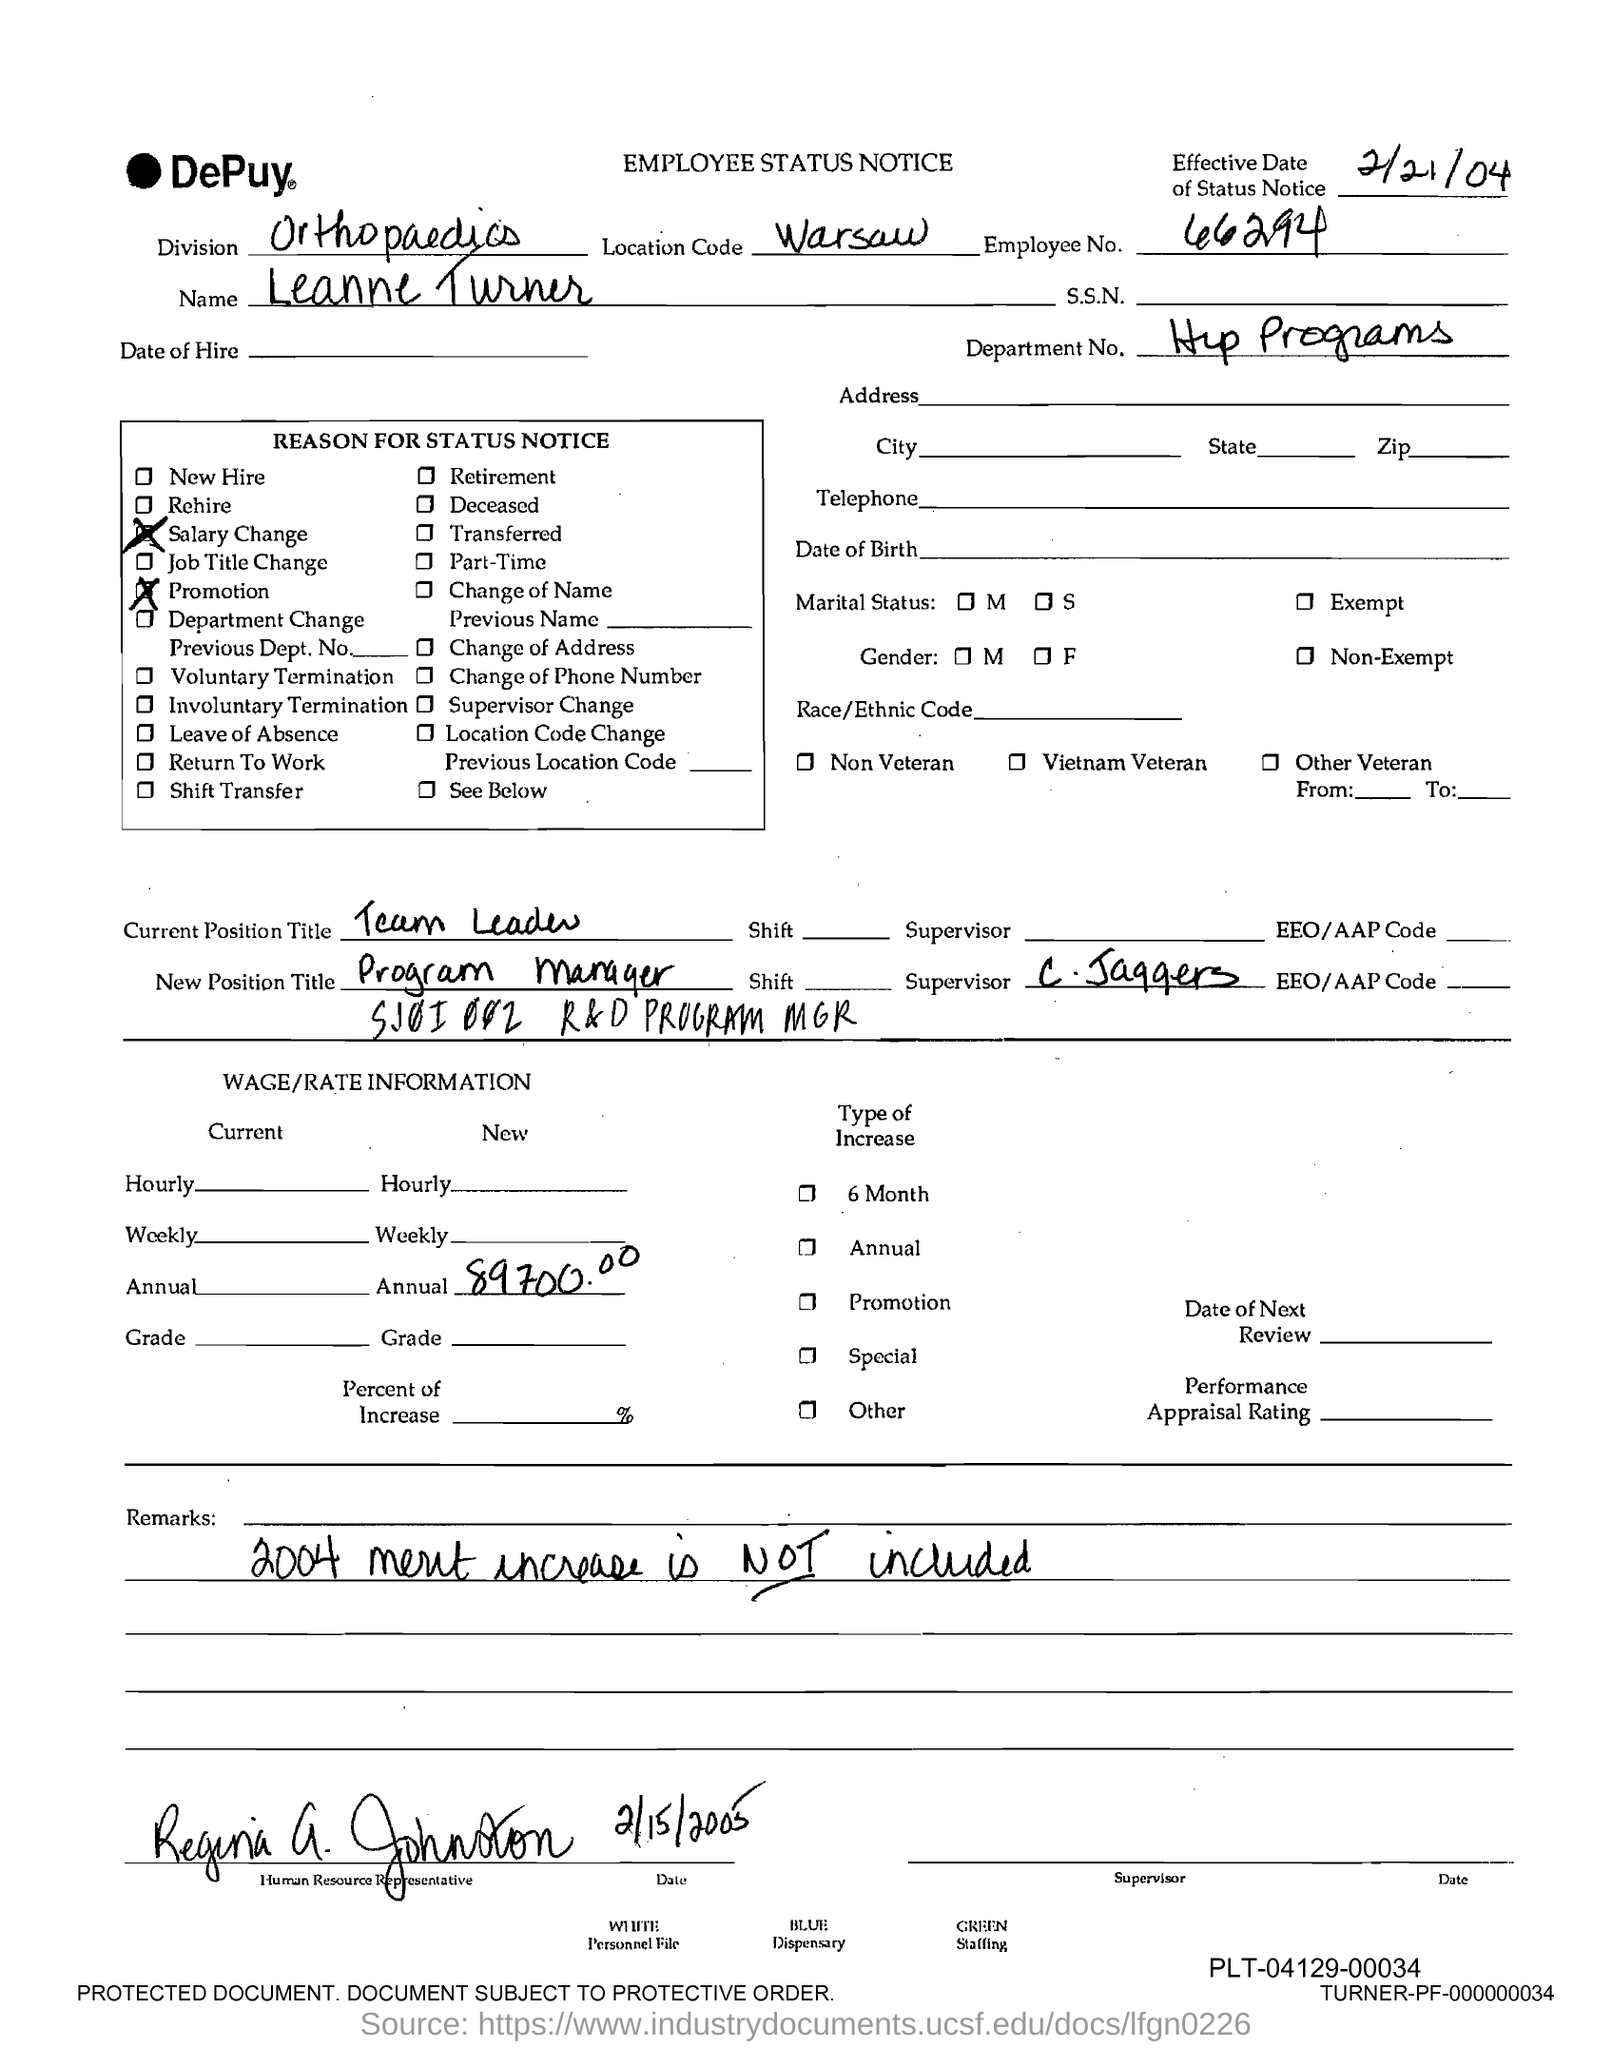What is the Employee No.?
Ensure brevity in your answer.  66294. What is the name of the Employee?
Provide a short and direct response. Leanne Turner. What is the Department No.?
Provide a short and direct response. Hip Programs. What is the location code?
Keep it short and to the point. Warsaw. What is the effective date of the status notice?
Offer a terse response. 2/21/04. What is the current position title?
Offer a terse response. Team Leader. What is the new position title?
Provide a succinct answer. Program manager. What is the remark provided?
Ensure brevity in your answer.  2004 merit increase is not included. What is the new annual Wage/rate information?
Ensure brevity in your answer.  89700.00. 